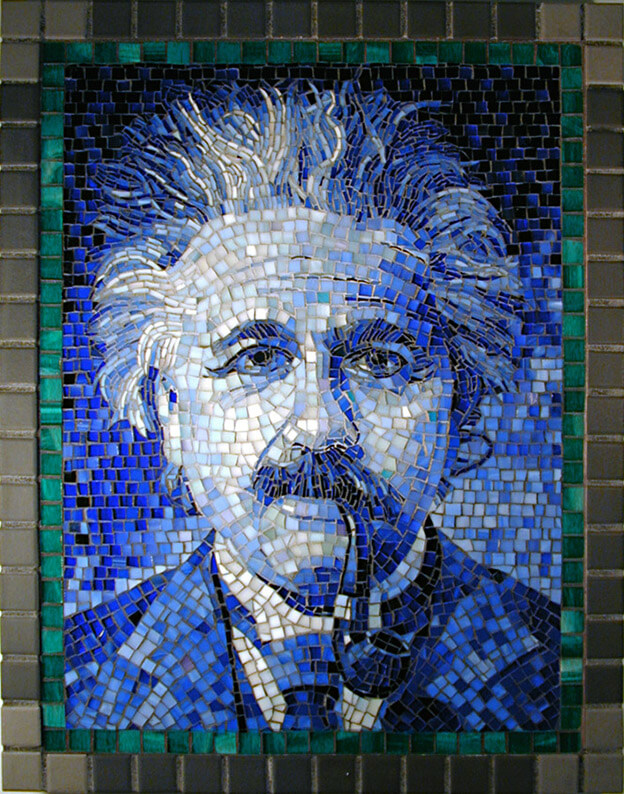What impact do you think the texture of the mosaic tiles has on the overall expression of the figure in the image? The texture of the mosaic tiles plays a critical role in conveying the emotional and intellectual essence of the figure. The uneven, yet harmonious arrangement of the tiles adds a dynamic quality to the portrait, suggesting a complexity in thoughts and emotions. It captures a certain rawness and immediacy, perhaps reflecting the figure's intense engagement with his intellectual pursuits. Furthermore, the slightly rugged texture could symbolize the laborious nature of thought processes, indicating that great ideas come from persistent and painstaking effort. 